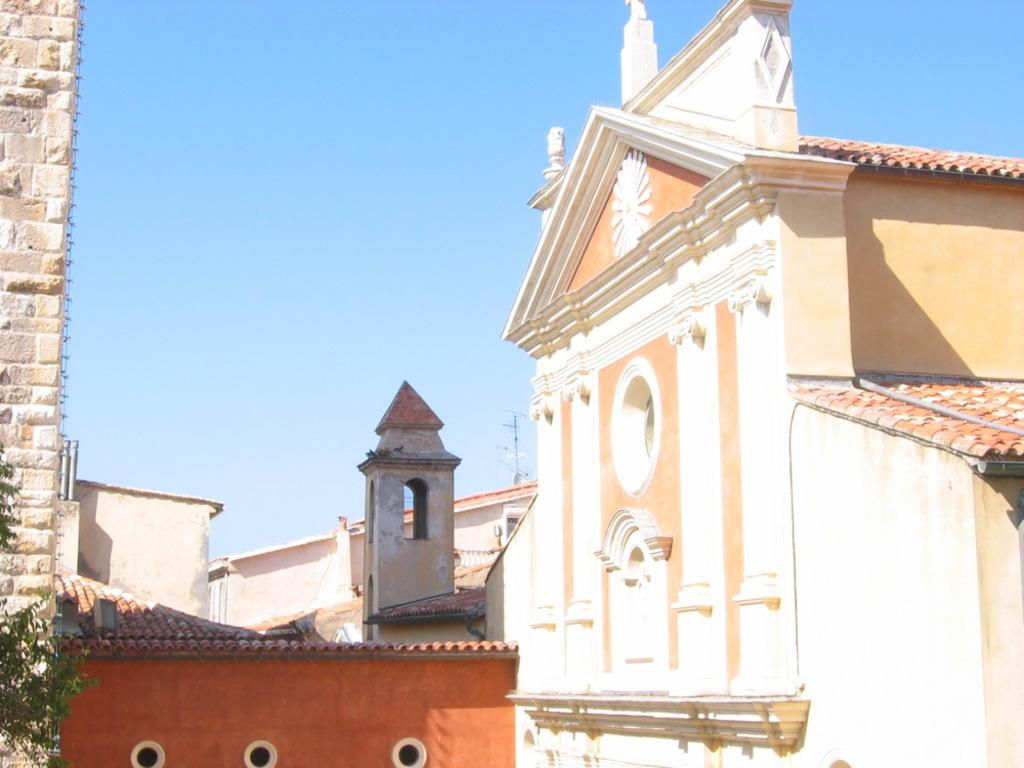What type of structures can be seen in the image? There are buildings in the image. What is located on the left side of the image? There is a brick wall on the left side of the image. Can you describe anything near the brick wall? There is a tree branch near the brick wall. What can be seen in the background of the image? The sky is visible in the background of the image. What type of coil is being used by the carpenter in the image? There is no carpenter or coil present in the image. 